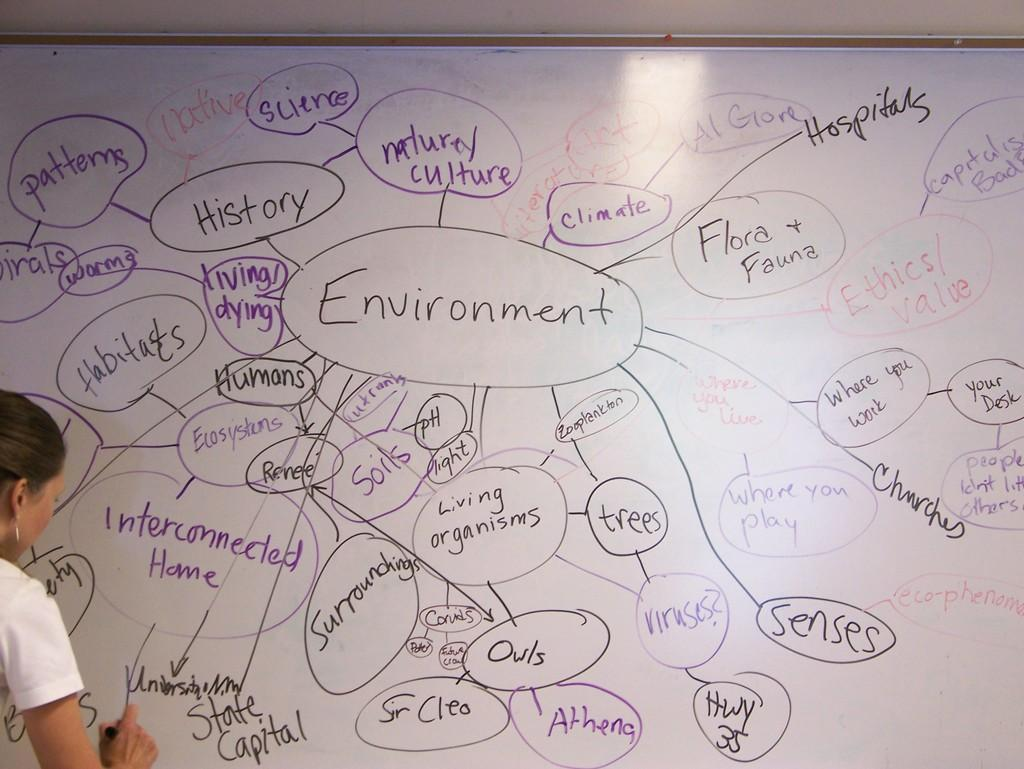Who is the main subject in the image? There is a woman in the image. What is the woman doing in the image? The woman is writing on a whiteboard. What type of bread is the woman using to write on the whiteboard? There is no bread present in the image; the woman is using a writing instrument to write on the whiteboard. 